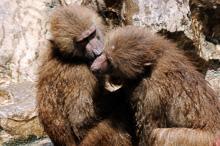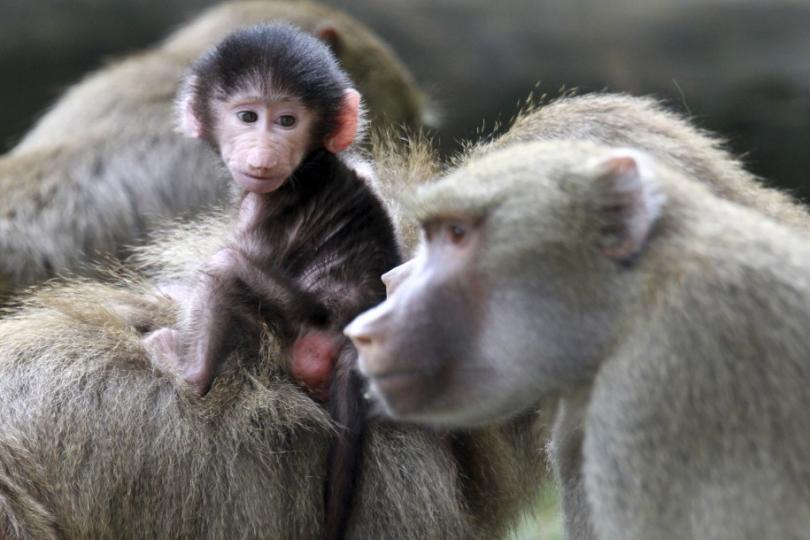The first image is the image on the left, the second image is the image on the right. Considering the images on both sides, is "An image contains two open-mouthed monkeys posed face-to-face." valid? Answer yes or no. No. 